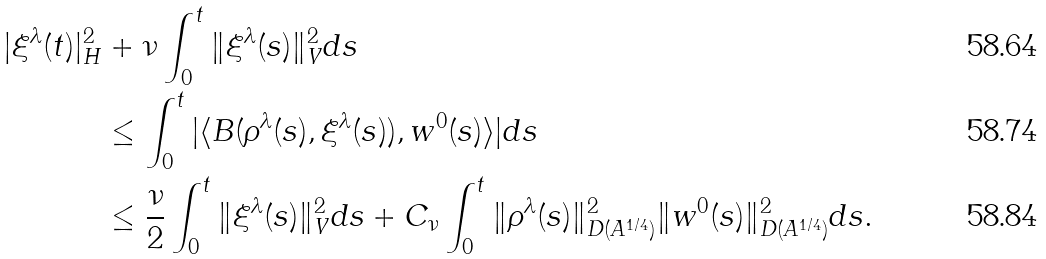Convert formula to latex. <formula><loc_0><loc_0><loc_500><loc_500>| \xi ^ { \lambda } ( t ) | _ { H } ^ { 2 } & + \nu \int _ { 0 } ^ { t } \| \xi ^ { \lambda } ( s ) \| _ { V } ^ { 2 } d s \\ & \leq \int _ { 0 } ^ { t } | \langle B ( \rho ^ { \lambda } ( s ) , \xi ^ { \lambda } ( s ) ) , w ^ { 0 } ( s ) \rangle | d s \\ & \leq \frac { \nu } { 2 } \int _ { 0 } ^ { t } \| \xi ^ { \lambda } ( s ) \| _ { V } ^ { 2 } d s + C _ { \nu } \int _ { 0 } ^ { t } \| \rho ^ { \lambda } ( s ) \| ^ { 2 } _ { D ( A ^ { 1 / 4 } ) } \| w ^ { 0 } ( s ) \| ^ { 2 } _ { D ( A ^ { 1 / 4 } ) } d s .</formula> 